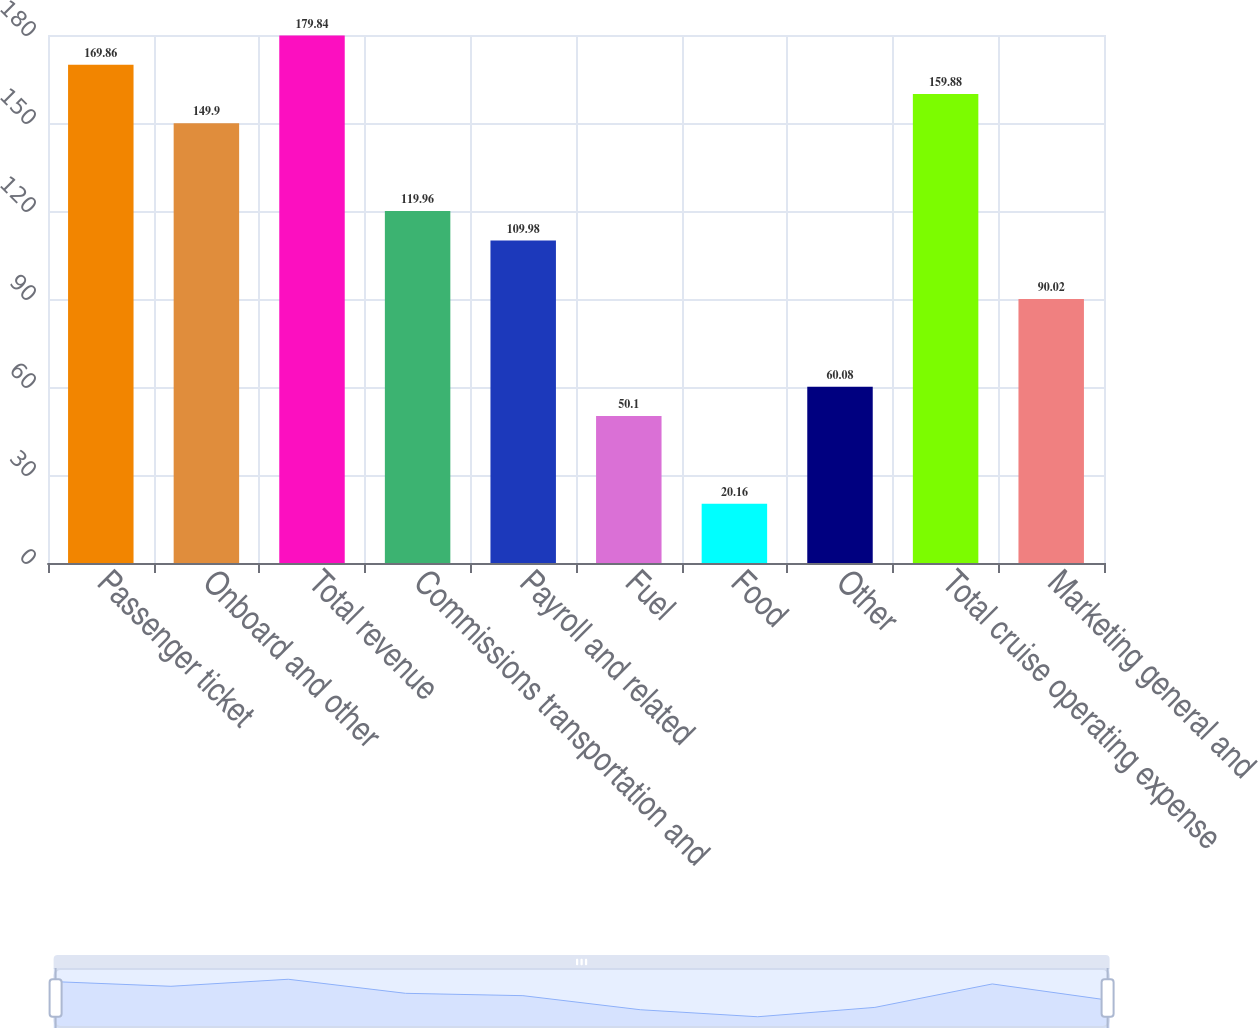Convert chart to OTSL. <chart><loc_0><loc_0><loc_500><loc_500><bar_chart><fcel>Passenger ticket<fcel>Onboard and other<fcel>Total revenue<fcel>Commissions transportation and<fcel>Payroll and related<fcel>Fuel<fcel>Food<fcel>Other<fcel>Total cruise operating expense<fcel>Marketing general and<nl><fcel>169.86<fcel>149.9<fcel>179.84<fcel>119.96<fcel>109.98<fcel>50.1<fcel>20.16<fcel>60.08<fcel>159.88<fcel>90.02<nl></chart> 